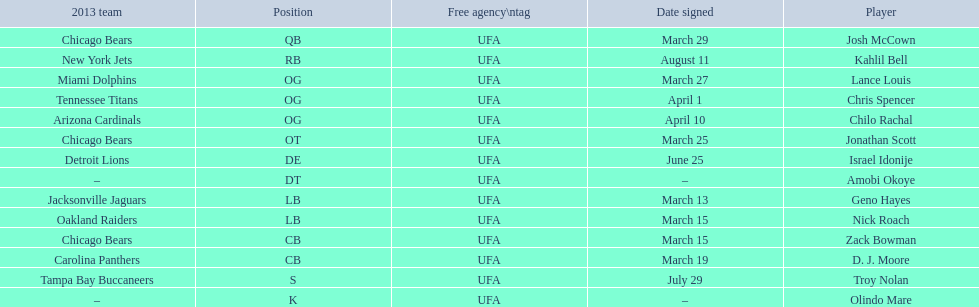Last name is also a first name beginning with "n" Troy Nolan. Parse the full table. {'header': ['2013 team', 'Position', 'Free agency\\ntag', 'Date signed', 'Player'], 'rows': [['Chicago Bears', 'QB', 'UFA', 'March 29', 'Josh McCown'], ['New York Jets', 'RB', 'UFA', 'August 11', 'Kahlil Bell'], ['Miami Dolphins', 'OG', 'UFA', 'March 27', 'Lance Louis'], ['Tennessee Titans', 'OG', 'UFA', 'April 1', 'Chris Spencer'], ['Arizona Cardinals', 'OG', 'UFA', 'April 10', 'Chilo Rachal'], ['Chicago Bears', 'OT', 'UFA', 'March 25', 'Jonathan Scott'], ['Detroit Lions', 'DE', 'UFA', 'June 25', 'Israel Idonije'], ['–', 'DT', 'UFA', '–', 'Amobi Okoye'], ['Jacksonville Jaguars', 'LB', 'UFA', 'March 13', 'Geno Hayes'], ['Oakland Raiders', 'LB', 'UFA', 'March 15', 'Nick Roach'], ['Chicago Bears', 'CB', 'UFA', 'March 15', 'Zack Bowman'], ['Carolina Panthers', 'CB', 'UFA', 'March 19', 'D. J. Moore'], ['Tampa Bay Buccaneers', 'S', 'UFA', 'July 29', 'Troy Nolan'], ['–', 'K', 'UFA', '–', 'Olindo Mare']]} 